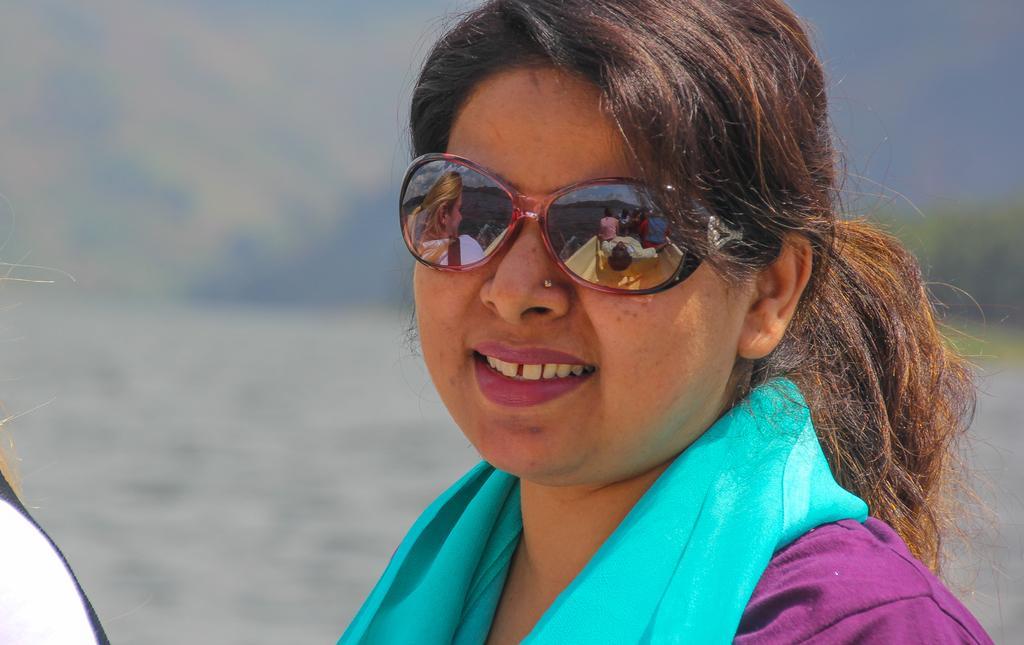In one or two sentences, can you explain what this image depicts? In the image a woman is smiling. Behind her there is water. 